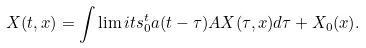Convert formula to latex. <formula><loc_0><loc_0><loc_500><loc_500>X ( t , x ) = \int \lim i t s _ { 0 } ^ { t } a ( t - \tau ) A X ( \tau , x ) d \tau + X _ { 0 } ( x ) .</formula> 